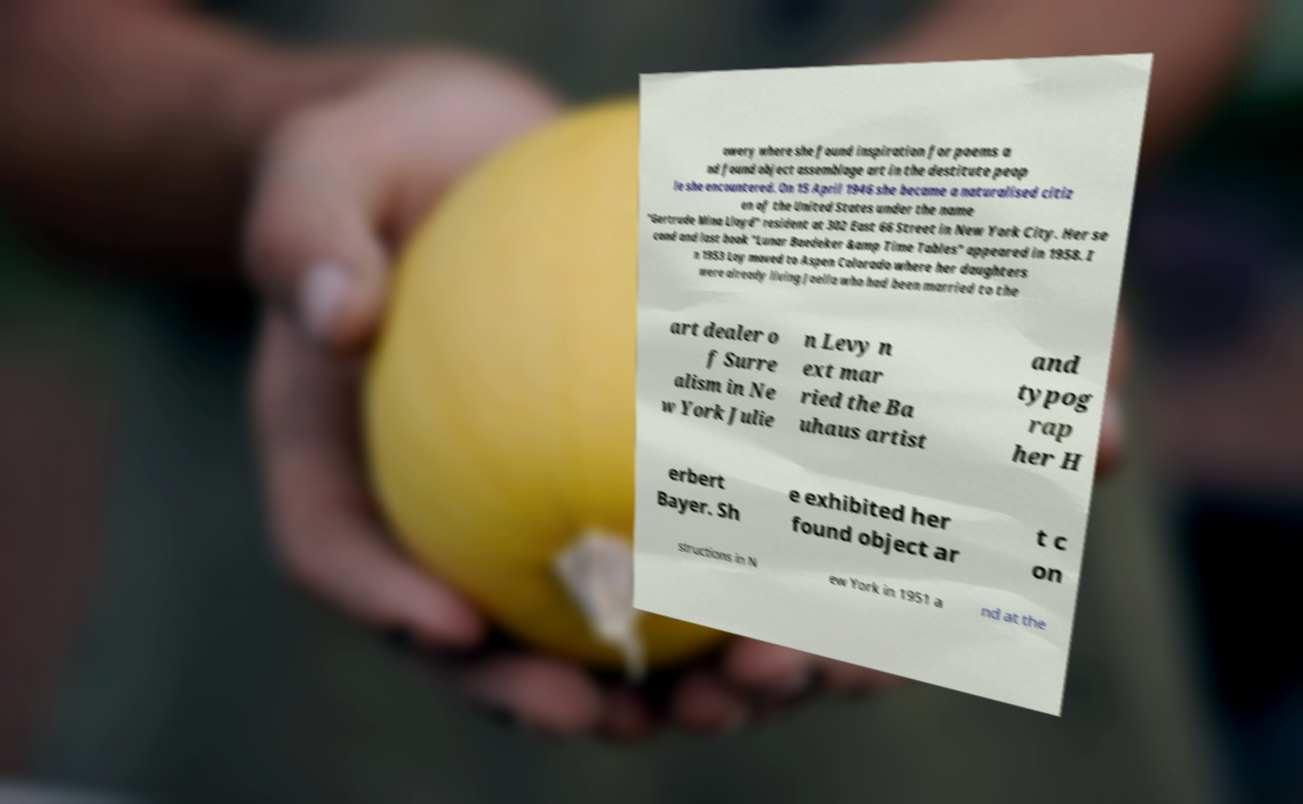There's text embedded in this image that I need extracted. Can you transcribe it verbatim? owery where she found inspiration for poems a nd found object assemblage art in the destitute peop le she encountered. On 15 April 1946 she became a naturalised citiz en of the United States under the name "Gertrude Mina Lloyd" resident at 302 East 66 Street in New York City. Her se cond and last book "Lunar Baedeker &amp Time Tables" appeared in 1958. I n 1953 Loy moved to Aspen Colorado where her daughters were already living Joella who had been married to the art dealer o f Surre alism in Ne w York Julie n Levy n ext mar ried the Ba uhaus artist and typog rap her H erbert Bayer. Sh e exhibited her found object ar t c on structions in N ew York in 1951 a nd at the 